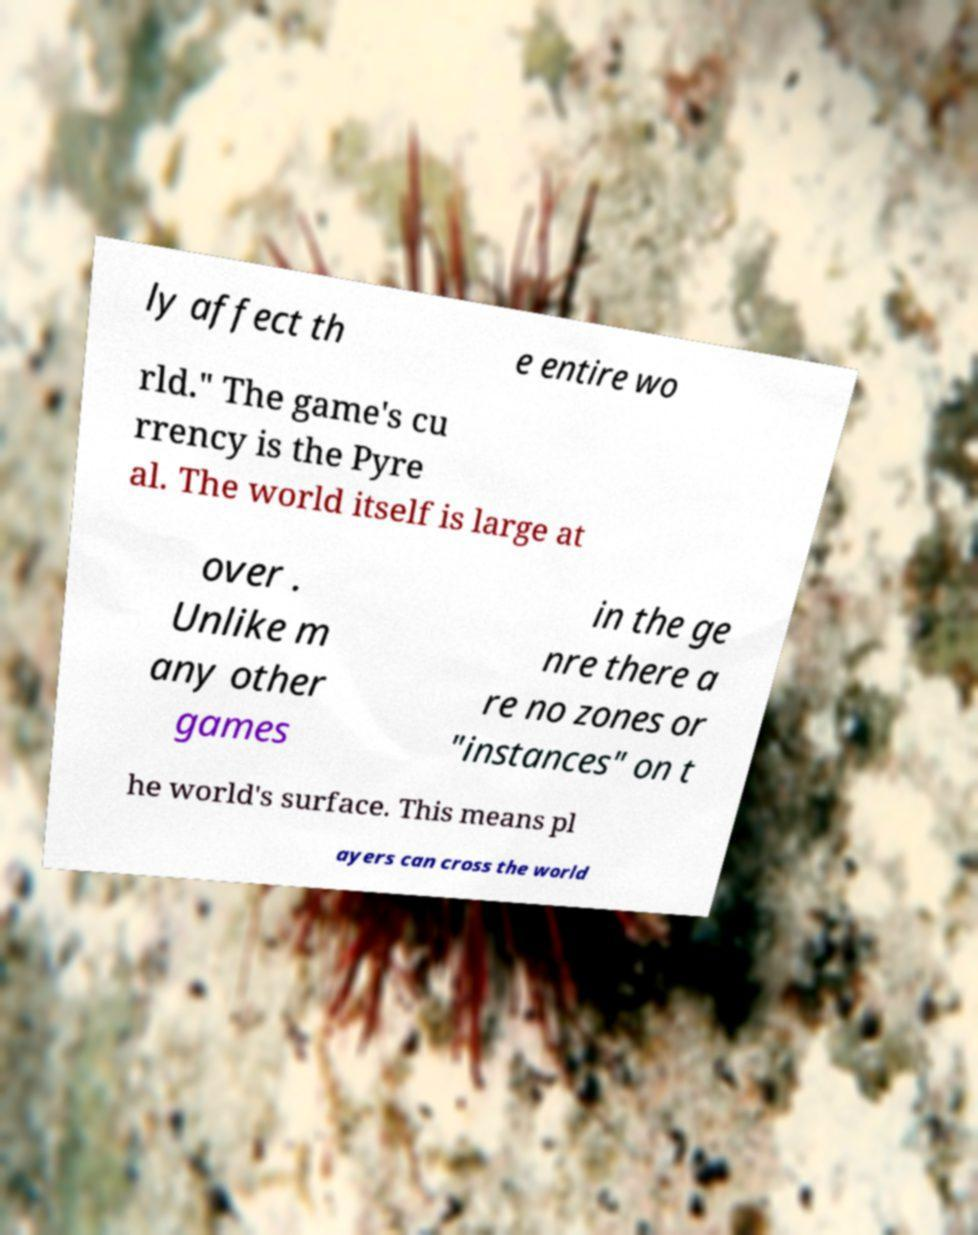Can you read and provide the text displayed in the image?This photo seems to have some interesting text. Can you extract and type it out for me? ly affect th e entire wo rld." The game's cu rrency is the Pyre al. The world itself is large at over . Unlike m any other games in the ge nre there a re no zones or "instances" on t he world's surface. This means pl ayers can cross the world 